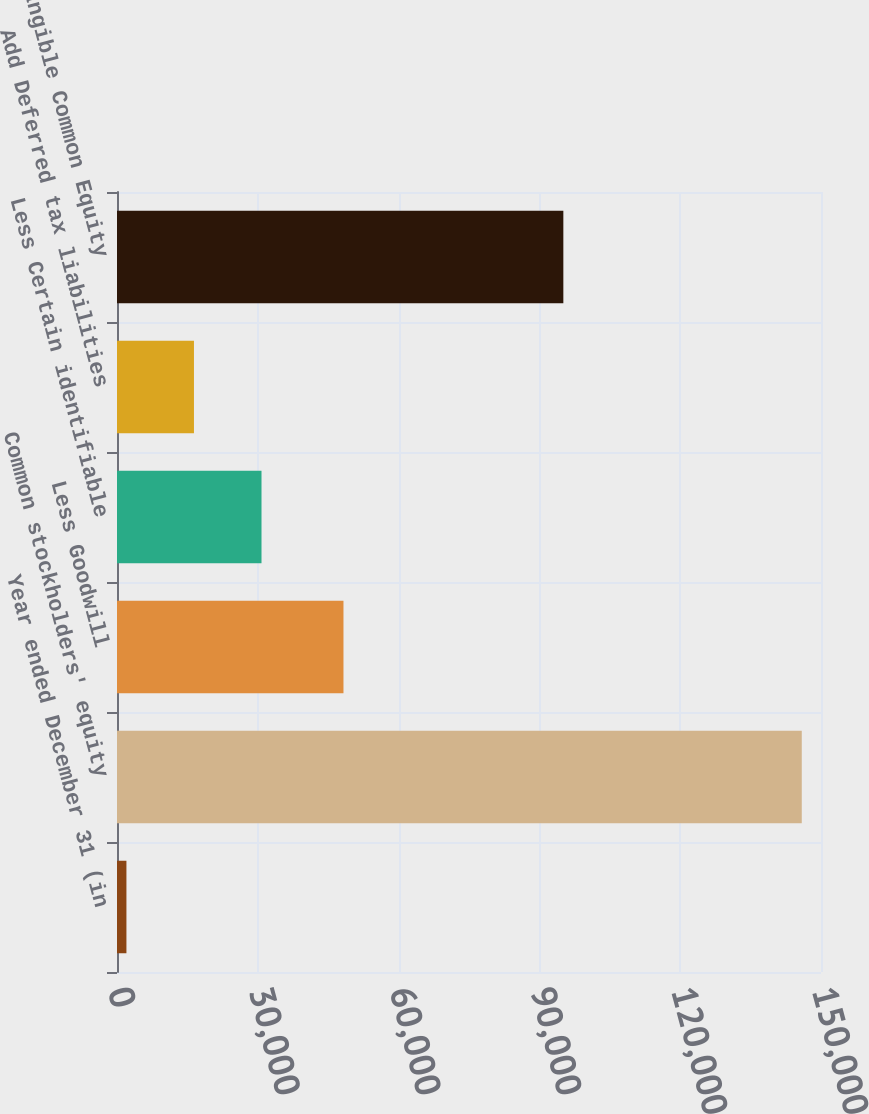Convert chart to OTSL. <chart><loc_0><loc_0><loc_500><loc_500><bar_chart><fcel>Year ended December 31 (in<fcel>Common stockholders' equity<fcel>Less Goodwill<fcel>Less Certain identifiable<fcel>Add Deferred tax liabilities<fcel>Tangible Common Equity<nl><fcel>2009<fcel>145903<fcel>48254<fcel>30787.8<fcel>16398.4<fcel>95101<nl></chart> 